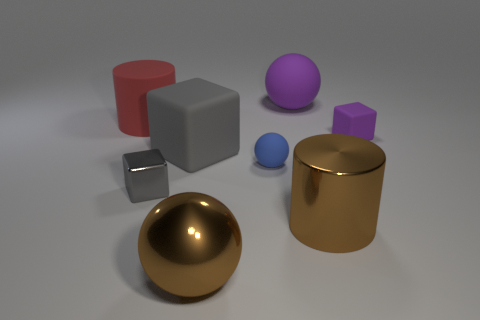Is the metal sphere the same color as the large metal cylinder? yes 